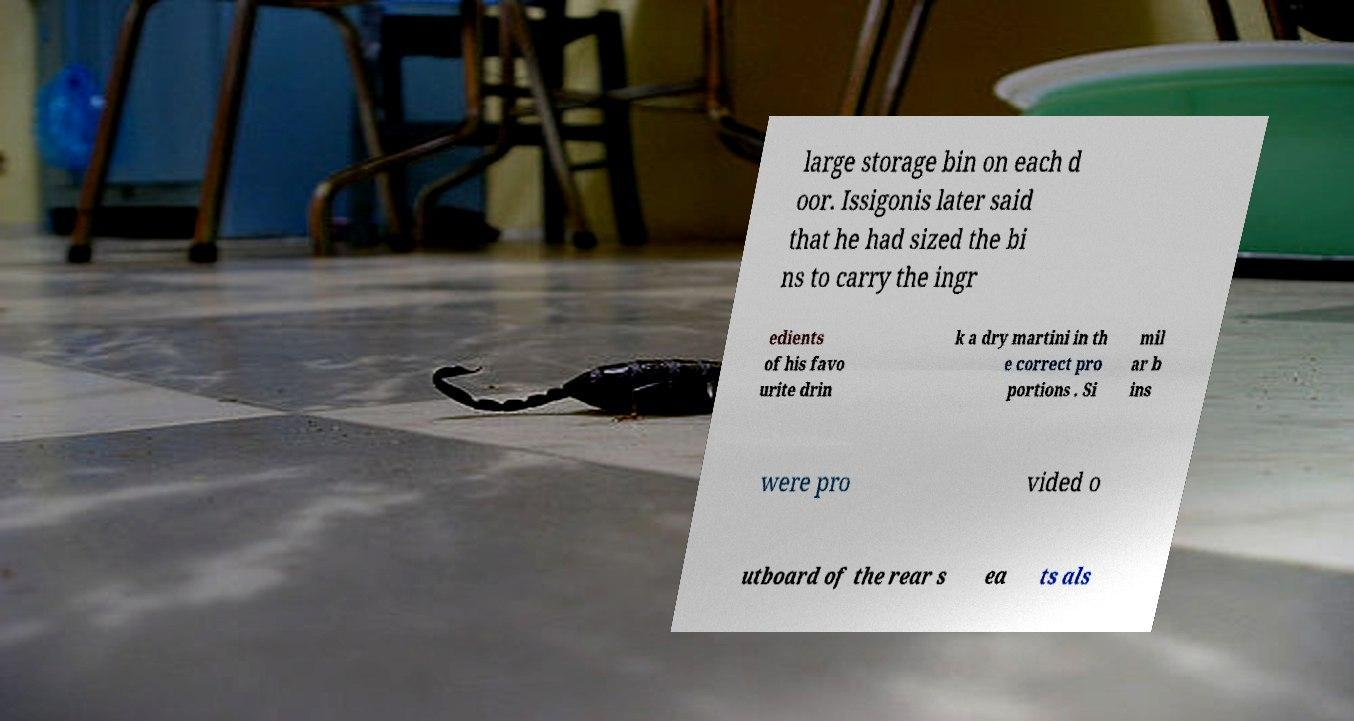For documentation purposes, I need the text within this image transcribed. Could you provide that? large storage bin on each d oor. Issigonis later said that he had sized the bi ns to carry the ingr edients of his favo urite drin k a dry martini in th e correct pro portions . Si mil ar b ins were pro vided o utboard of the rear s ea ts als 